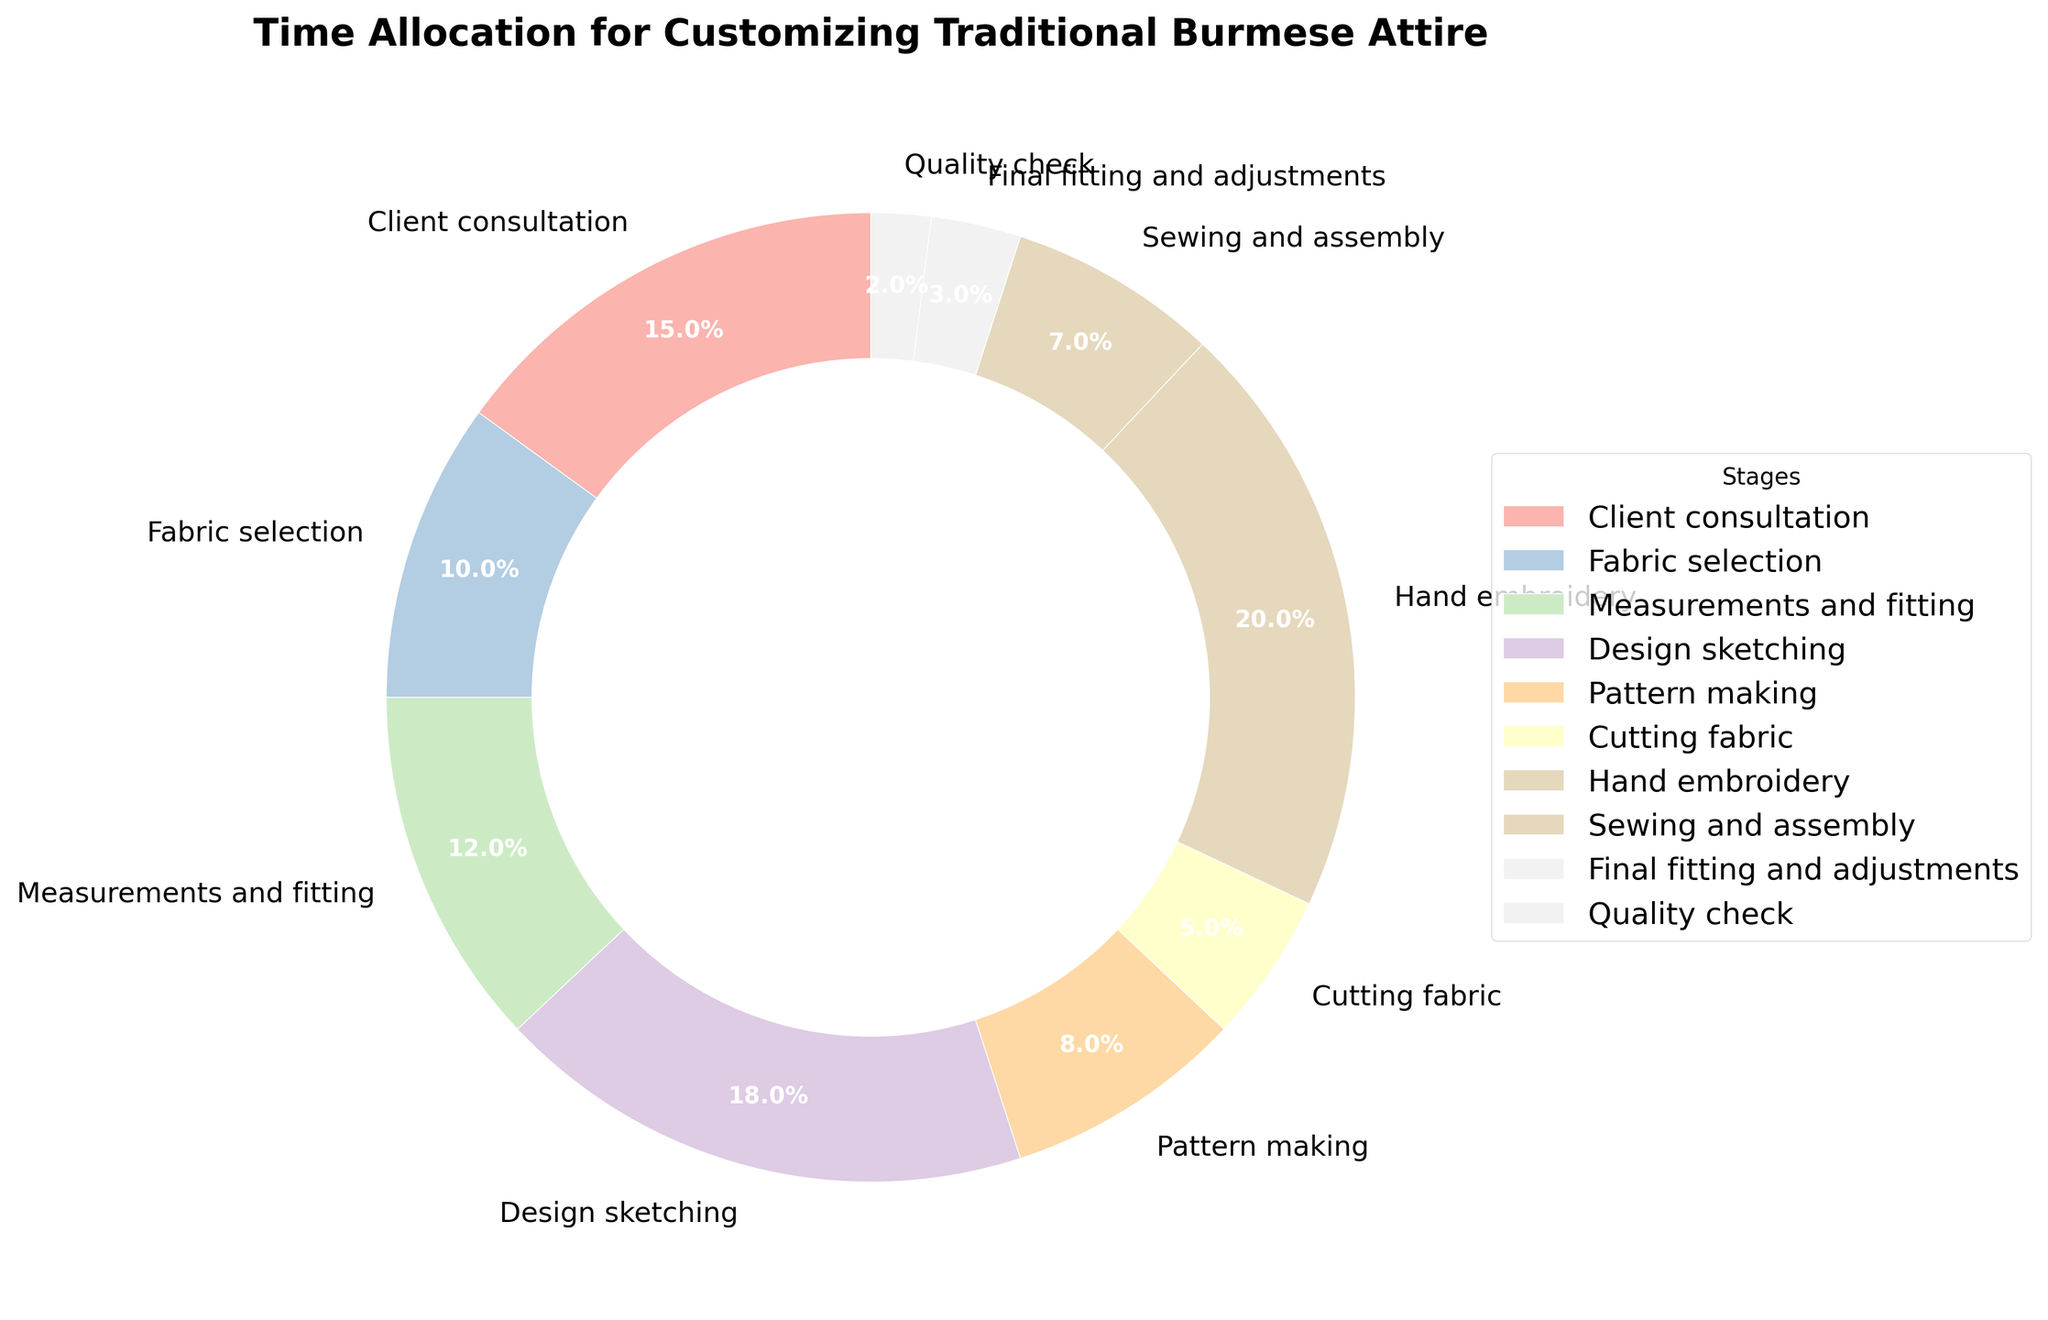What's the percentage allocated to Fabric selection? Look at the pie chart section labeled "Fabric selection" and read the percentage shown.
Answer: 10% What's the total percentage spent on Hand embroidery and Quality check? Sum the percentages for Hand embroidery (20%) and Quality check (2%) by finding their slices in the pie chart and adding them together. 20% + 2% = 22%
Answer: 22% Which stage takes up the largest portion of the time? Identify the largest wedge in the pie chart to determine which stage has the highest percentage. It should be labeled accordingly.
Answer: Hand embroidery How much more time is spent on Design sketching compared to Cutting fabric? Find the percentages for Design sketching (18%) and Cutting fabric (5%) in the pie chart. Subtract the Cutting fabric percentage from the Design sketching percentage. 18% - 5% = 13%
Answer: 13% What are the top three stages in terms of time allocation? Identify the three largest wedges in the pie chart by their size and the percentages labeled on them.
Answer: Hand embroidery, Design sketching, Client consultation What is the combined time spent on Client consultation, Fabric selection, and Measurements and fitting? Sum the percentages for Client consultation (15%), Fabric selection (10%), and Measurements and fitting (12%) by identifying their respective slices in the pie chart and adding them together. 15% + 10% + 12% = 37%
Answer: 37% Is more time spent on Pattern making or Final fitting and adjustments? Compare the wedges for Pattern making (8%) and Final fitting and adjustments (3%) in the pie chart.
Answer: Pattern making Which stage has the lowest time allocation? Look for the smallest wedge in the pie chart to find which stage has the smallest percentage.
Answer: Quality check By how much does Hand embroidery exceed the time allocation for Measurements and fitting? Subtract the percentage for Measurements and fitting (12%) from the percentage for Hand embroidery (20%) by referring to the respective wedges in the pie chart. 20% - 12% = 8%
Answer: 8% 